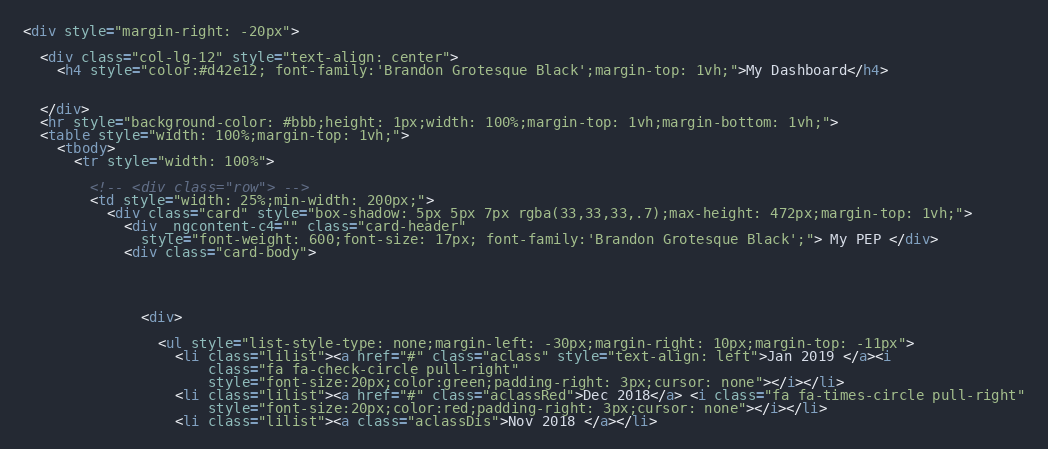<code> <loc_0><loc_0><loc_500><loc_500><_HTML_><div style="margin-right: -20px">

  <div class="col-lg-12" style="text-align: center">
    <h4 style="color:#d42e12; font-family:'Brandon Grotesque Black';margin-top: 1vh;">My Dashboard</h4>


  </div>
  <hr style="background-color: #bbb;height: 1px;width: 100%;margin-top: 1vh;margin-bottom: 1vh;">
  <table style="width: 100%;margin-top: 1vh;">
    <tbody>
      <tr style="width: 100%">

        <!-- <div class="row"> -->
        <td style="width: 25%;min-width: 200px;">
          <div class="card" style="box-shadow: 5px 5px 7px rgba(33,33,33,.7);max-height: 472px;margin-top: 1vh;">
            <div _ngcontent-c4="" class="card-header"
              style="font-weight: 600;font-size: 17px; font-family:'Brandon Grotesque Black';"> My PEP </div>
            <div class="card-body">




              <div>

                <ul style="list-style-type: none;margin-left: -30px;margin-right: 10px;margin-top: -11px">
                  <li class="lilist"><a href="#" class="aclass" style="text-align: left">Jan 2019 </a><i
                      class="fa fa-check-circle pull-right"
                      style="font-size:20px;color:green;padding-right: 3px;cursor: none"></i></li>
                  <li class="lilist"><a href="#" class="aclassRed">Dec 2018</a> <i class="fa fa-times-circle pull-right"
                      style="font-size:20px;color:red;padding-right: 3px;cursor: none"></i></li>
                  <li class="lilist"><a class="aclassDis">Nov 2018 </a></li></code> 